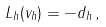<formula> <loc_0><loc_0><loc_500><loc_500>L _ { h } ( v _ { h } ) = - d _ { h } \, ,</formula> 